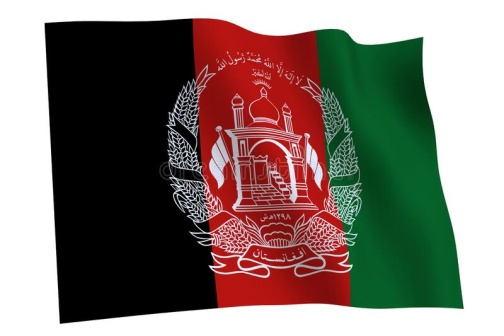What does each color on the Afghan flag represent? The colors of the Afghan flag hold deep meanings. The black stripe represents the dark history of foreign domination, red symbolizes the blood shed in the struggle for independence, and green stands for hope and prosperity in the future of Afghanistan. 